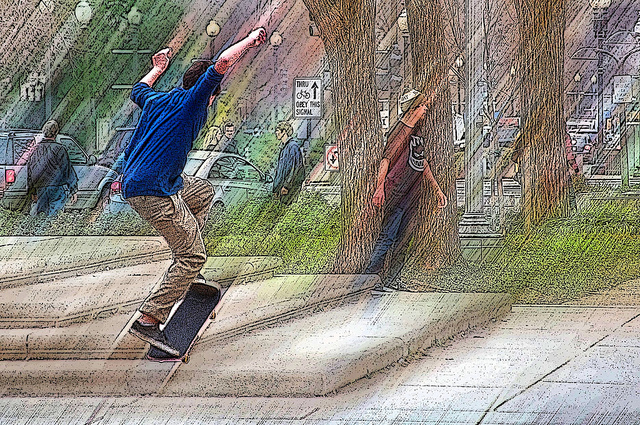Please identify all text content in this image. OBEY THIS SIGNAL 